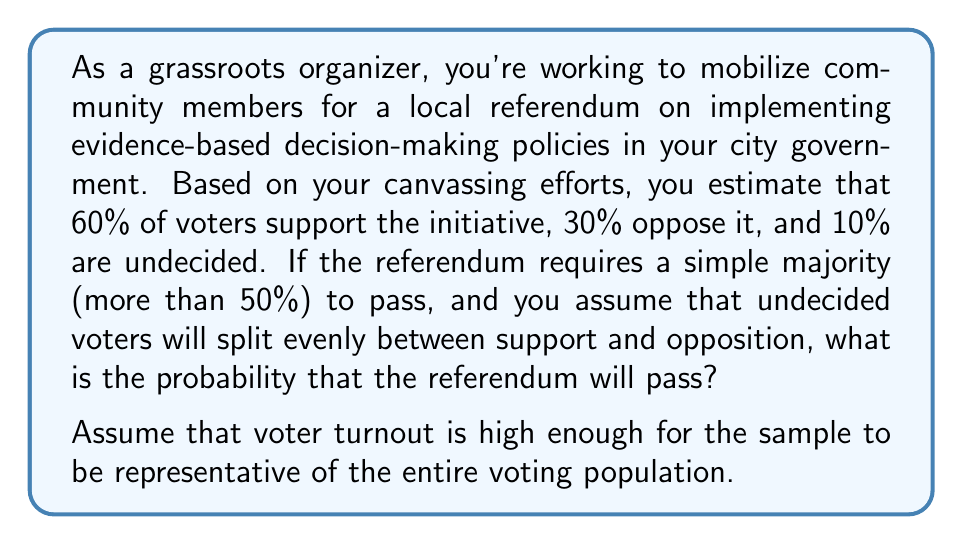Teach me how to tackle this problem. Let's approach this step-by-step:

1) First, we need to distribute the undecided voters. Since they're assumed to split evenly:
   - Half of the 10% undecided will support: $0.05$ or $5\%$
   - Half will oppose: $0.05$ or $5\%$

2) Now, let's recalculate the final proportions:
   - Support: $60\% + 5\% = 65\%$ or $0.65$
   - Oppose: $30\% + 5\% = 35\%$ or $0.35$

3) For the referendum to pass, we need more than 50% support. We already have this, so the probability is simply the proportion of supporters.

4) Therefore, the probability of the referendum passing is $0.65$ or $65\%$.

This can be represented mathematically as:

$$P(\text{referendum passes}) = P(\text{support} > 0.5) = 0.65$$

It's worth noting that this assumes perfect representation of the population in the vote and no sampling error in your initial estimates. In a real-world scenario, there would likely be some margin of error to consider.
Answer: The probability that the referendum will pass is $0.65$ or $65\%$. 